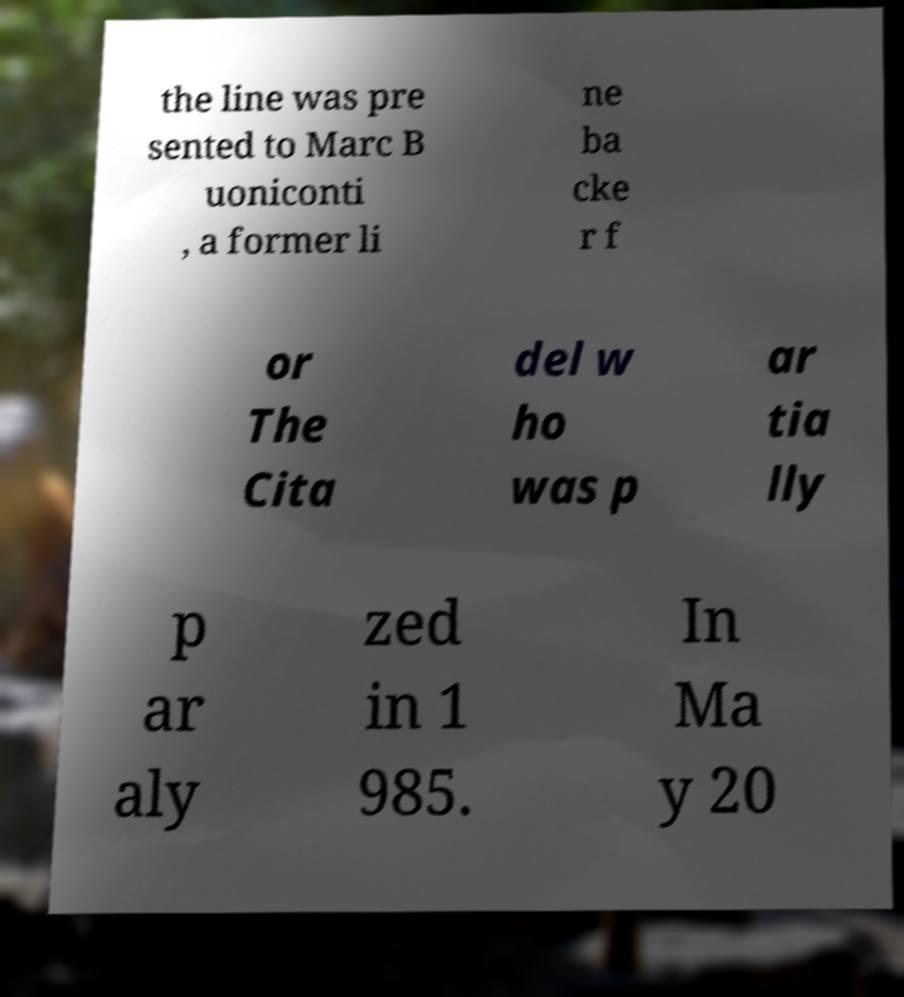Could you extract and type out the text from this image? the line was pre sented to Marc B uoniconti , a former li ne ba cke r f or The Cita del w ho was p ar tia lly p ar aly zed in 1 985. In Ma y 20 